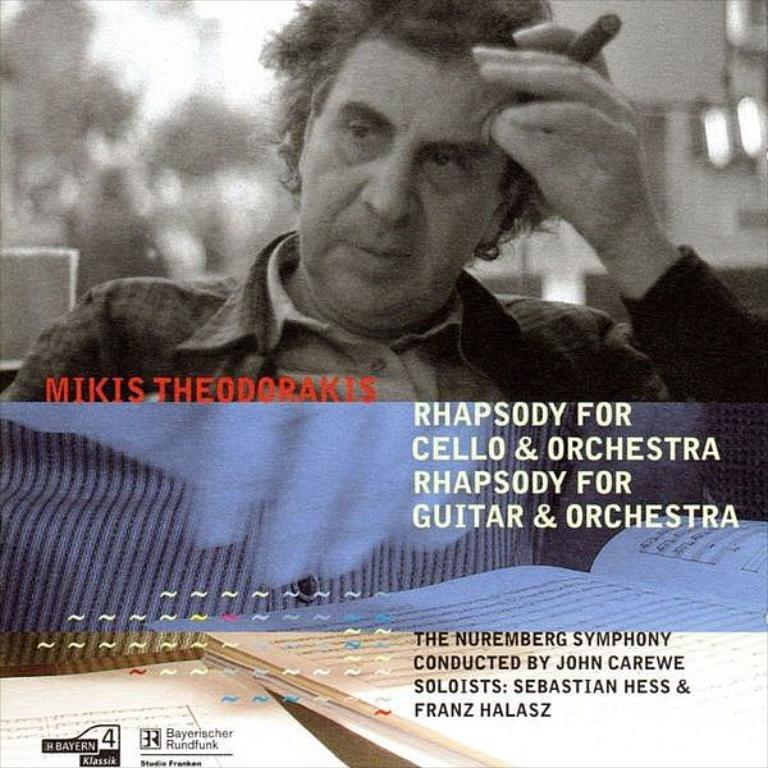What is the man in the image doing? The man is sitting in the image. What is the man holding in the image? The man is holding an object. Can you describe any written text in the image? Yes, there is written text in the image. How does the man taste the object he is holding in the image? The image does not show the man tasting the object he is holding, so it cannot be determined from the image. 